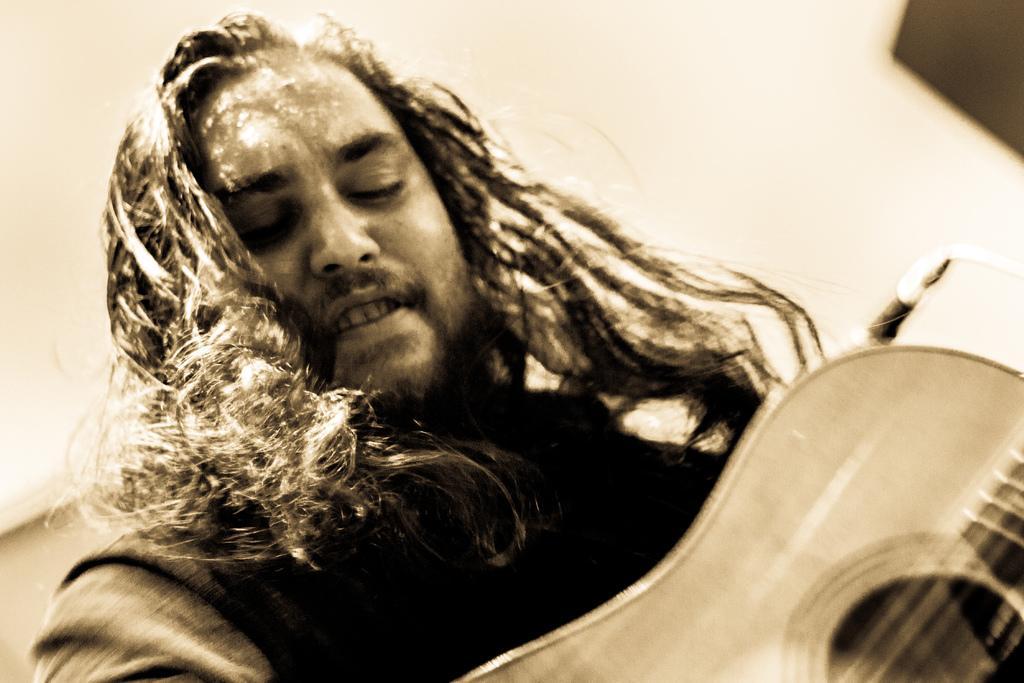In one or two sentences, can you explain what this image depicts? a person is holding a guitar , is having a long hair. behind him there is a microphone. 